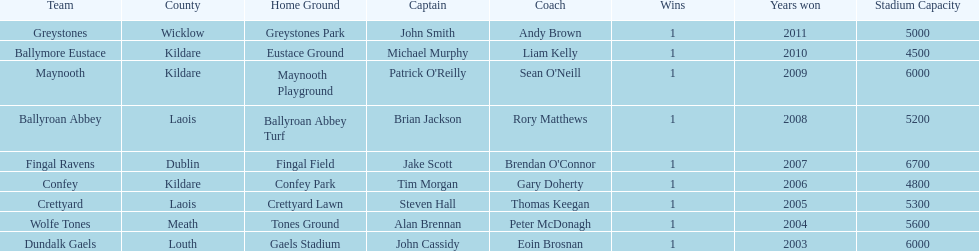How many wins does greystones have? 1. 